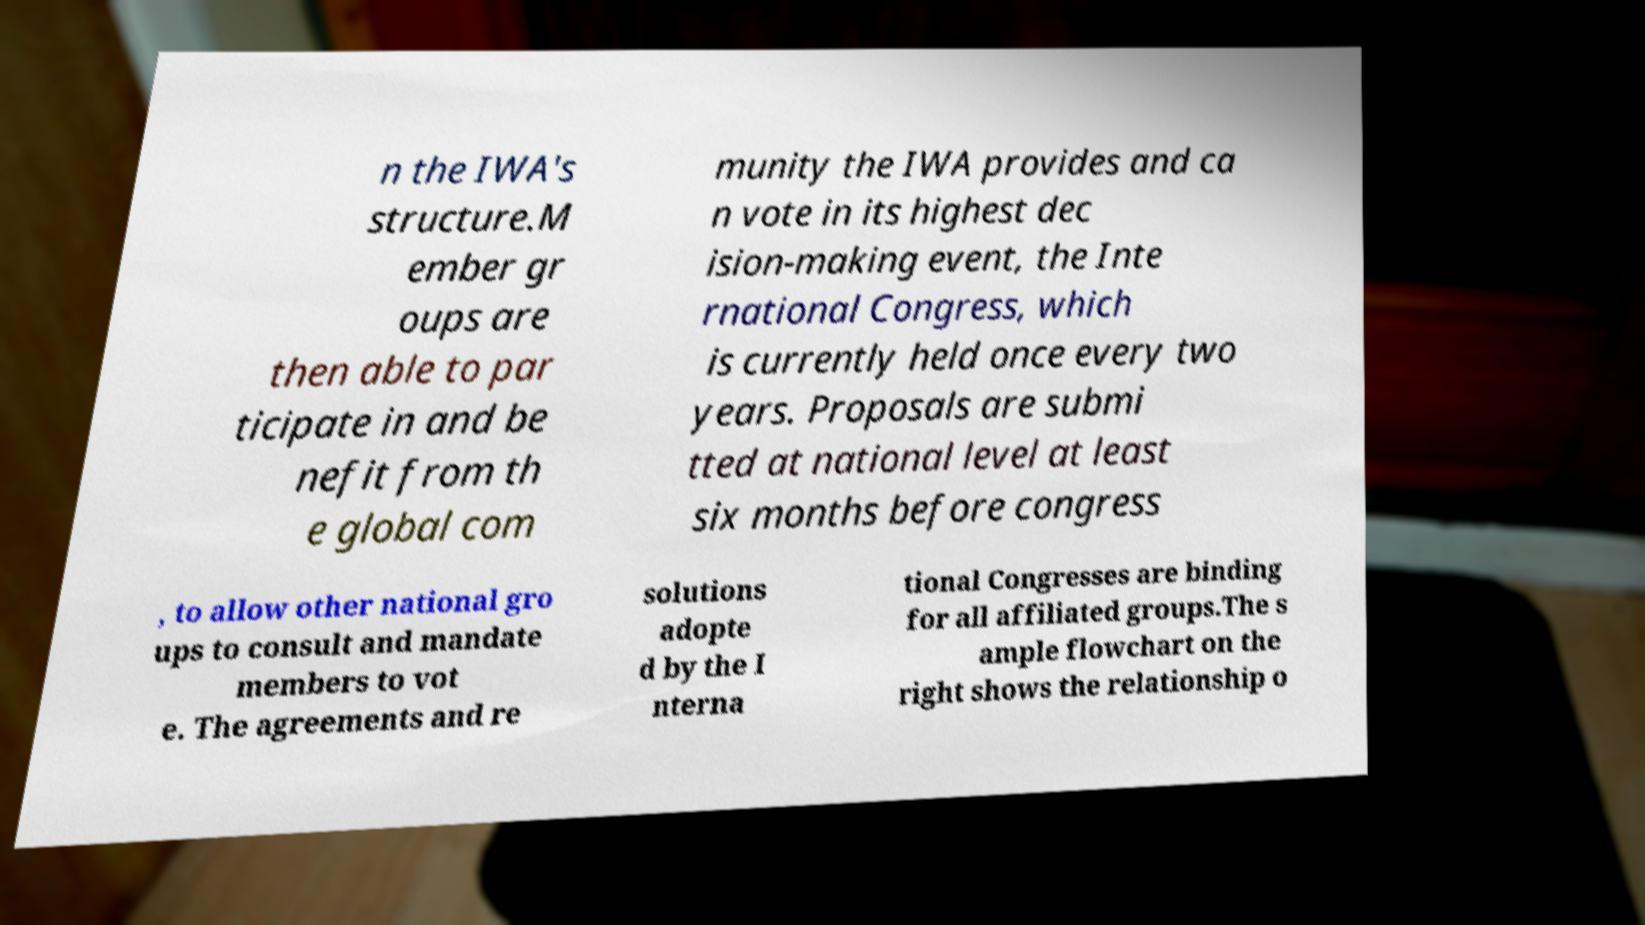There's text embedded in this image that I need extracted. Can you transcribe it verbatim? n the IWA's structure.M ember gr oups are then able to par ticipate in and be nefit from th e global com munity the IWA provides and ca n vote in its highest dec ision-making event, the Inte rnational Congress, which is currently held once every two years. Proposals are submi tted at national level at least six months before congress , to allow other national gro ups to consult and mandate members to vot e. The agreements and re solutions adopte d by the I nterna tional Congresses are binding for all affiliated groups.The s ample flowchart on the right shows the relationship o 